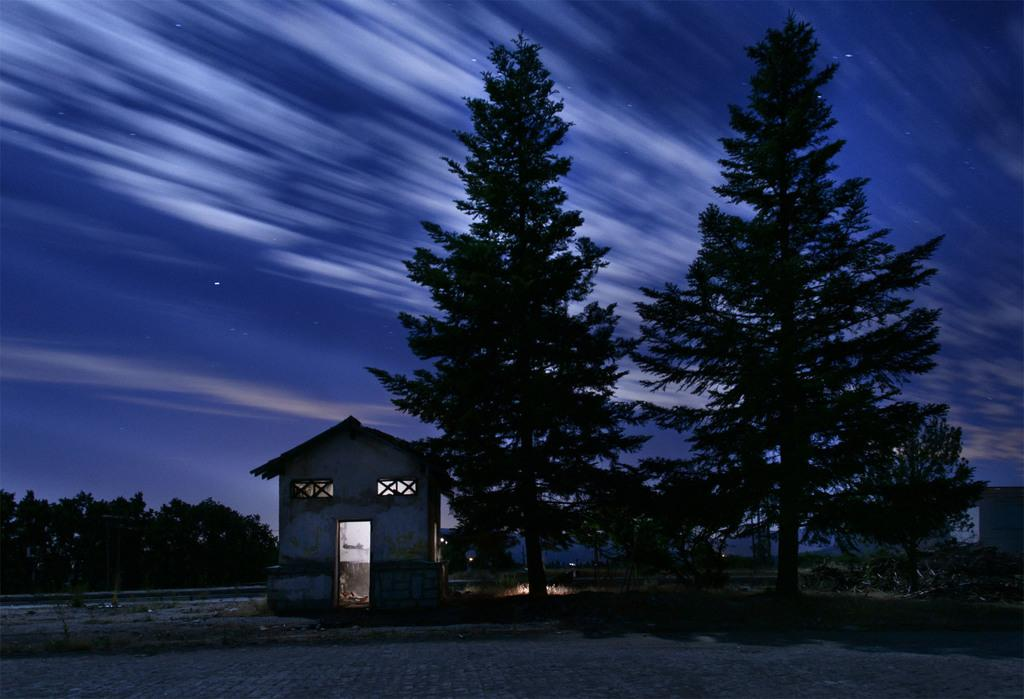What is the lighting condition in the image? The image was taken in the dark. What can be seen in the middle of the image? There are many trees and houses in the middle of the image. What is visible at the top of the image? The sky is visible at the top of the image. Can you see any goats or squirrels causing destruction in the image? There are no goats, squirrels, or any destruction present in the image. 